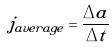Convert formula to latex. <formula><loc_0><loc_0><loc_500><loc_500>j _ { a v e r a g e } = \frac { \Delta a } { \Delta t }</formula> 